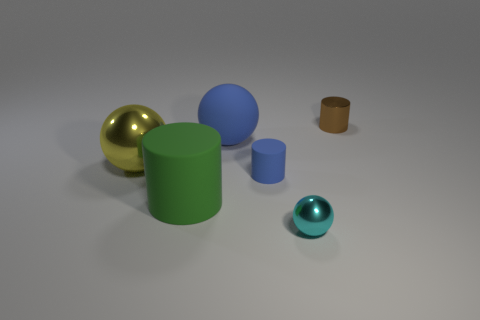Subtract 1 spheres. How many spheres are left? 2 Subtract all tiny brown metallic cylinders. How many cylinders are left? 2 Add 3 tiny rubber cylinders. How many objects exist? 9 Subtract all blue spheres. How many spheres are left? 2 Subtract 0 purple balls. How many objects are left? 6 Subtract all blue cylinders. Subtract all yellow cubes. How many cylinders are left? 2 Subtract all green balls. How many green cylinders are left? 1 Subtract all cyan matte balls. Subtract all small blue cylinders. How many objects are left? 5 Add 3 brown objects. How many brown objects are left? 4 Add 4 large green rubber cubes. How many large green rubber cubes exist? 4 